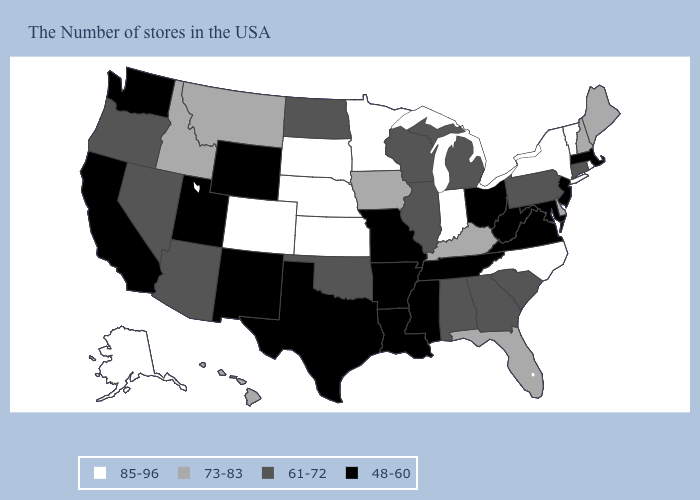Which states hav the highest value in the MidWest?
Short answer required. Indiana, Minnesota, Kansas, Nebraska, South Dakota. Among the states that border Vermont , does New York have the highest value?
Be succinct. Yes. Which states hav the highest value in the South?
Short answer required. North Carolina. Name the states that have a value in the range 61-72?
Keep it brief. Connecticut, Pennsylvania, South Carolina, Georgia, Michigan, Alabama, Wisconsin, Illinois, Oklahoma, North Dakota, Arizona, Nevada, Oregon. Does Montana have a higher value than Delaware?
Quick response, please. No. Name the states that have a value in the range 85-96?
Be succinct. Rhode Island, Vermont, New York, North Carolina, Indiana, Minnesota, Kansas, Nebraska, South Dakota, Colorado, Alaska. What is the value of Michigan?
Be succinct. 61-72. What is the value of South Dakota?
Write a very short answer. 85-96. Which states have the lowest value in the MidWest?
Concise answer only. Ohio, Missouri. What is the value of Pennsylvania?
Answer briefly. 61-72. Which states hav the highest value in the Northeast?
Concise answer only. Rhode Island, Vermont, New York. Does California have the highest value in the USA?
Quick response, please. No. Does New Jersey have the same value as Texas?
Give a very brief answer. Yes. Which states have the highest value in the USA?
Give a very brief answer. Rhode Island, Vermont, New York, North Carolina, Indiana, Minnesota, Kansas, Nebraska, South Dakota, Colorado, Alaska. Does the first symbol in the legend represent the smallest category?
Answer briefly. No. 